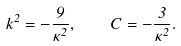Convert formula to latex. <formula><loc_0><loc_0><loc_500><loc_500>k ^ { 2 } = - \frac { 9 } { \kappa ^ { 2 } } , \quad C = - \frac { 3 } { \kappa ^ { 2 } } .</formula> 